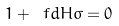<formula> <loc_0><loc_0><loc_500><loc_500>1 + \ f d { H } { \sigma } = 0</formula> 